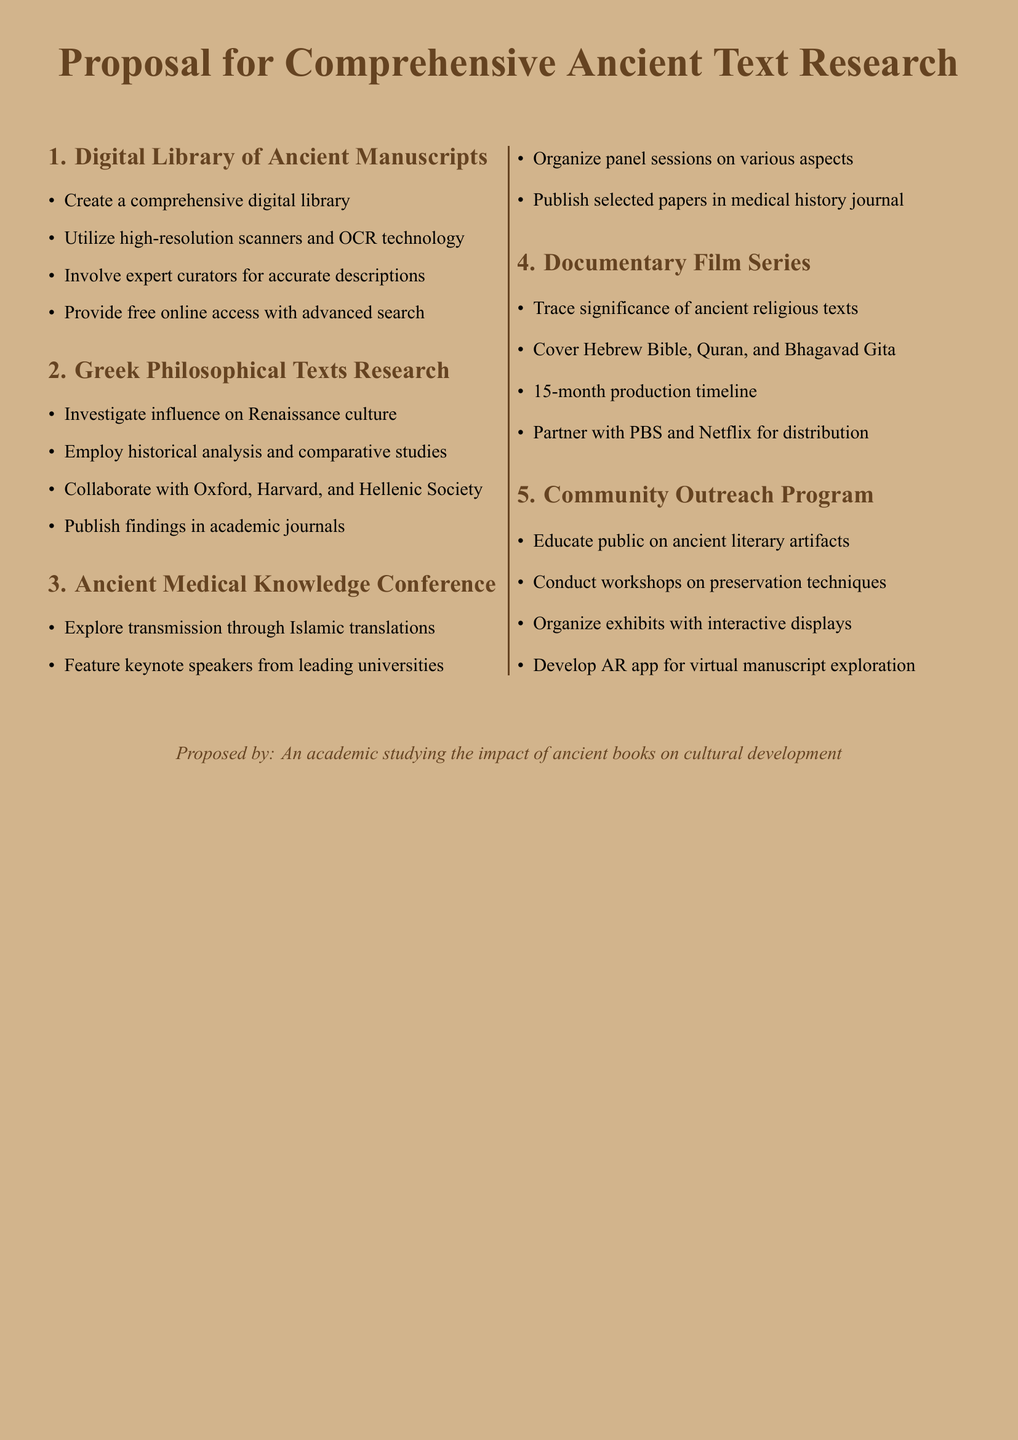What is the title of the document? The title of the document is specified at the beginning, describing the focus on ancient text research.
Answer: Proposal for Comprehensive Ancient Text Research Who are the collaborative partners for the Greek Philosophical Texts Research? The document lists Oxford, Harvard, and the Hellenic Society as collaborative partners.
Answer: Oxford, Harvard, Hellenic Society How many months is the production timeline for the Documentary Film Series? The production timeline for the Documentary Film Series is explicitly stated in the document.
Answer: 15 months What technology will be utilized for the digital library? The document mentions high-resolution scanners and OCR technology for the digital library.
Answer: High-resolution scanners and OCR technology What is the main goal of the Community Outreach Program? The document outlines the aim of the program, focusing on educating the public about ancient literary artifacts.
Answer: Educate public on ancient literary artifacts How will selected papers from the conference be published? The document specifies that selected papers will be published in a specific type of journal.
Answer: Medical history journal What ancient texts will the Documentary Film Series cover? The document explicitly lists the texts to be covered in the series.
Answer: Hebrew Bible, Quran, Bhagavad Gita What is the proposed method for public access to the digital library? The document states that there will be free online access with an advanced search feature.
Answer: Free online access with advanced search 